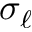<formula> <loc_0><loc_0><loc_500><loc_500>\sigma _ { \ell }</formula> 